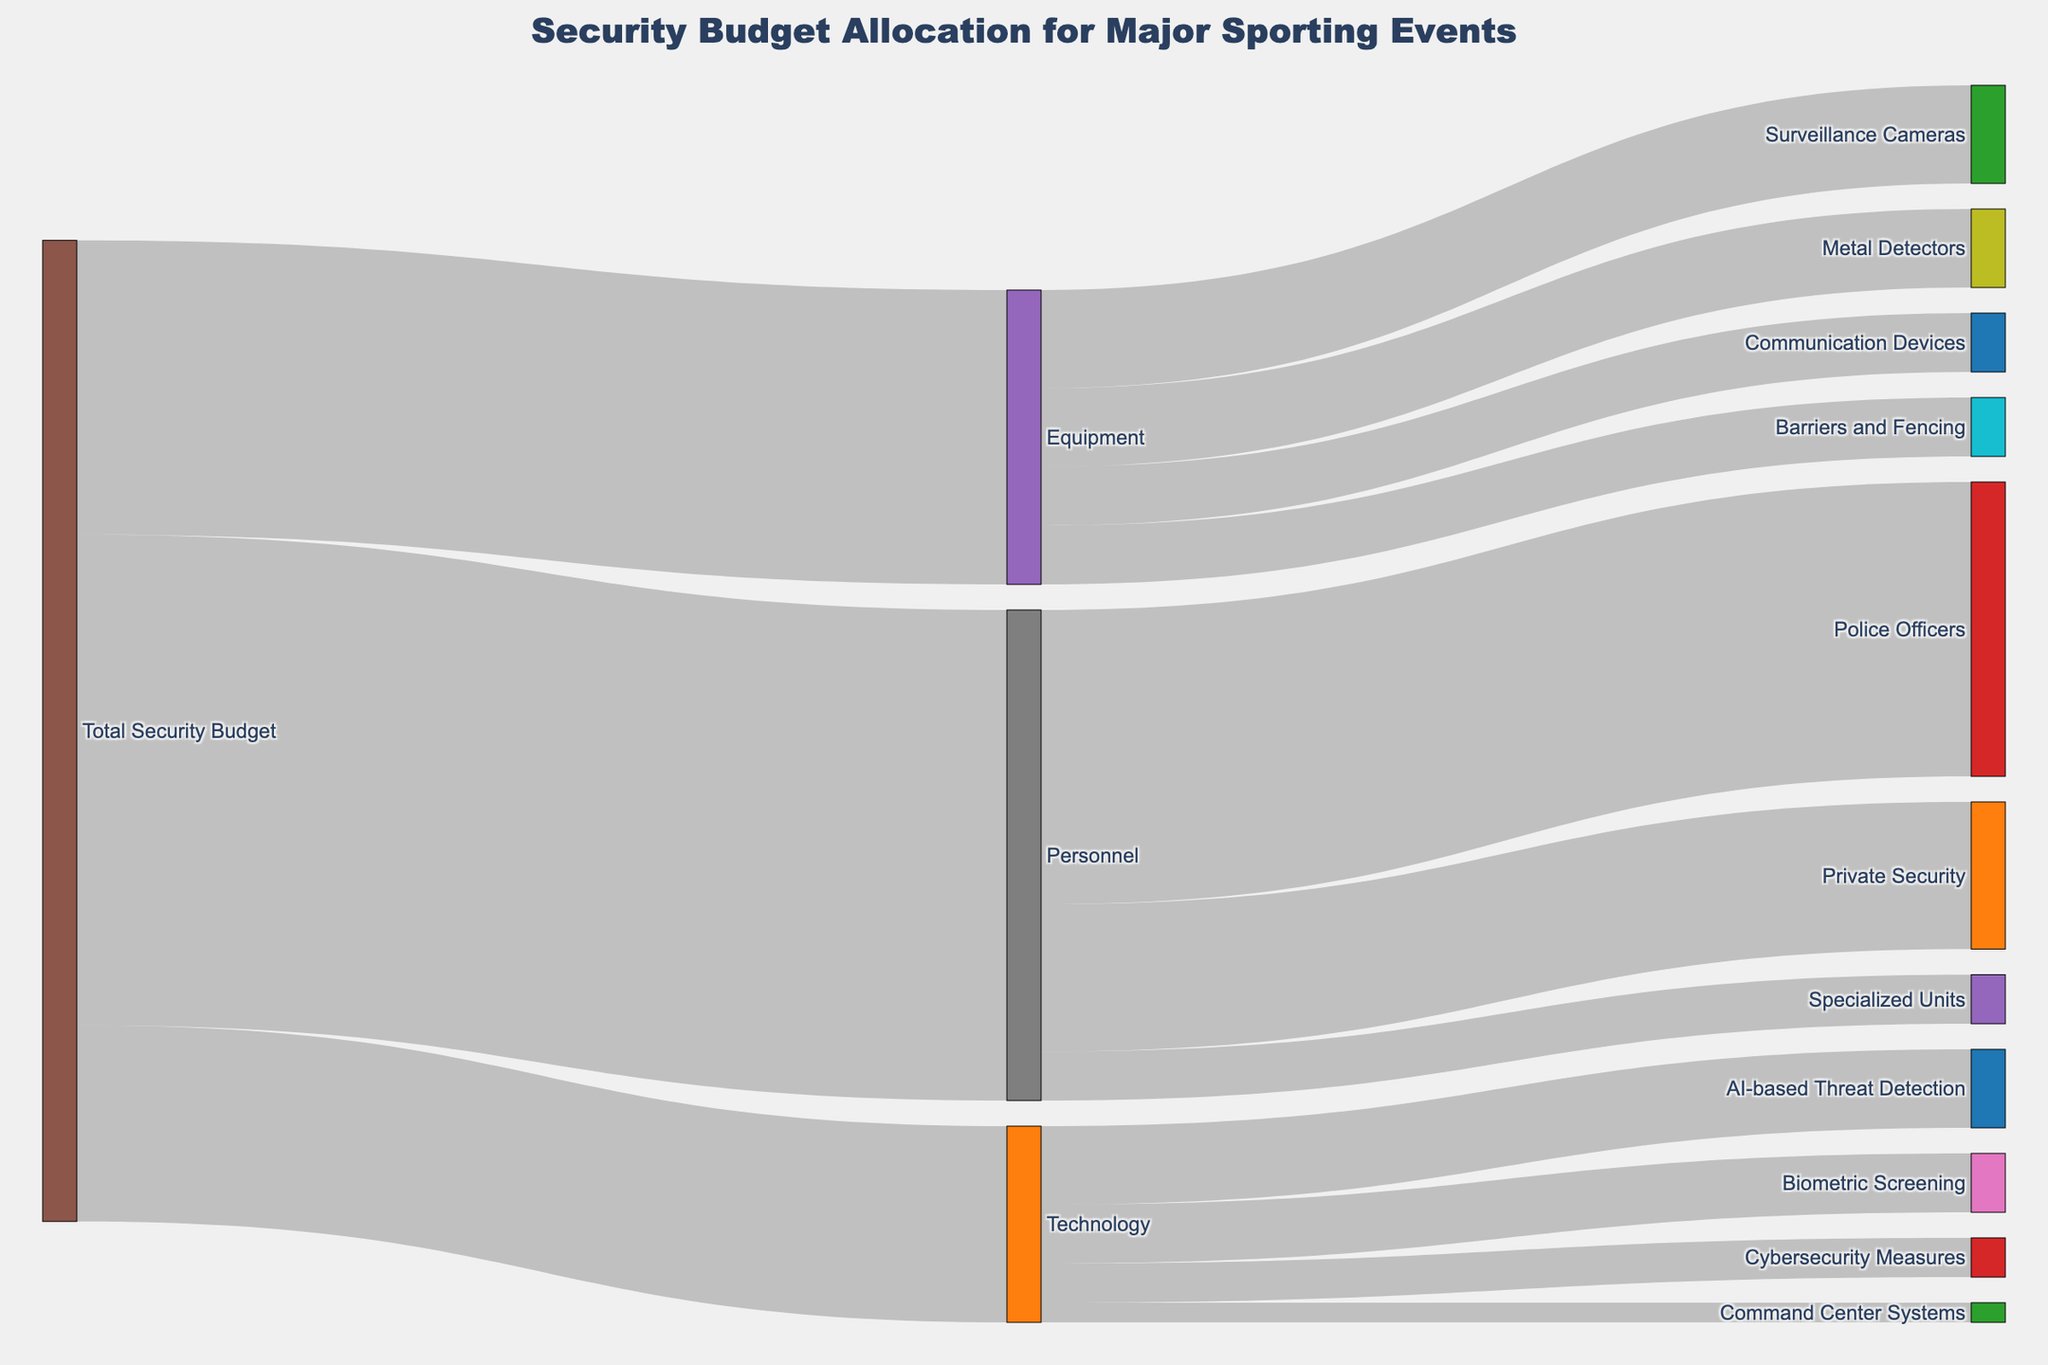What is the title of the Sankey diagram? The title is usually displayed at the top of the figure to provide a summary of the content. Here, it indicates the focus of the Sankey diagram on security budget allocation for major sporting events.
Answer: Security Budget Allocation for Major Sporting Events How much of the total security budget is allocated to technology? In the diagram, "Total Security Budget" is the source and "Technology" is the target. The value associated with this link shows the part of the budget allocated to technology.
Answer: 2,000,000 Which personnel category receives the highest portion of the budget? Look at the branches extending from "Personnel". The branch with the highest value indicates the category that receives the most budget, which in this case is "Police Officers".
Answer: Police Officers What is the combined budget for communication devices and metal detectors? Identify the values for "Communication Devices" and "Metal Detectors" under "Equipment", and then sum them up (600,000 + 800,000).
Answer: 1,400,000 Compare the allocation for Cybersecurity Measures and Biometric Screening. Which one has a higher budget? Look at the values for "Cybersecurity Measures" and "Biometric Screening" under "Technology". Compare the two values to determine which is higher.
Answer: Biometric Screening What is the total amount allocated to personnel? The value associated with the link from "Total Security Budget" to "Personnel" provides this information directly.
Answer: 5,000,000 Which category under Equipment has the lowest budget and what is that amount? Look for the smallest value among the targets under "Equipment" to find the category with the lowest budget.
Answer: Barriers and Fencing, 600,000 How do the budgets allocated to AI-based Threat Detection and Command Center Systems compare? What is the difference between them? Look at the values for "AI-based Threat Detection" and "Command Center Systems" under "Technology". Subtract the lower value from the higher value (800,000 - 200,000).
Answer: AI-based Threat Detection has a budget that is 600,000 higher than Command Center Systems Considering Personnel and Equipment, which category under these receives the highest budget and what is it? Compare the highest values under "Personnel" and "Equipment". The highest value will indicate the category that receives the most budget.
Answer: Police Officers, 3,000,000 How much budget is allocated to specialized units within personnel? Look for the value that links "Personnel" to "Specialized Units" to determine the budget allocated to specialized units.
Answer: 500,000 